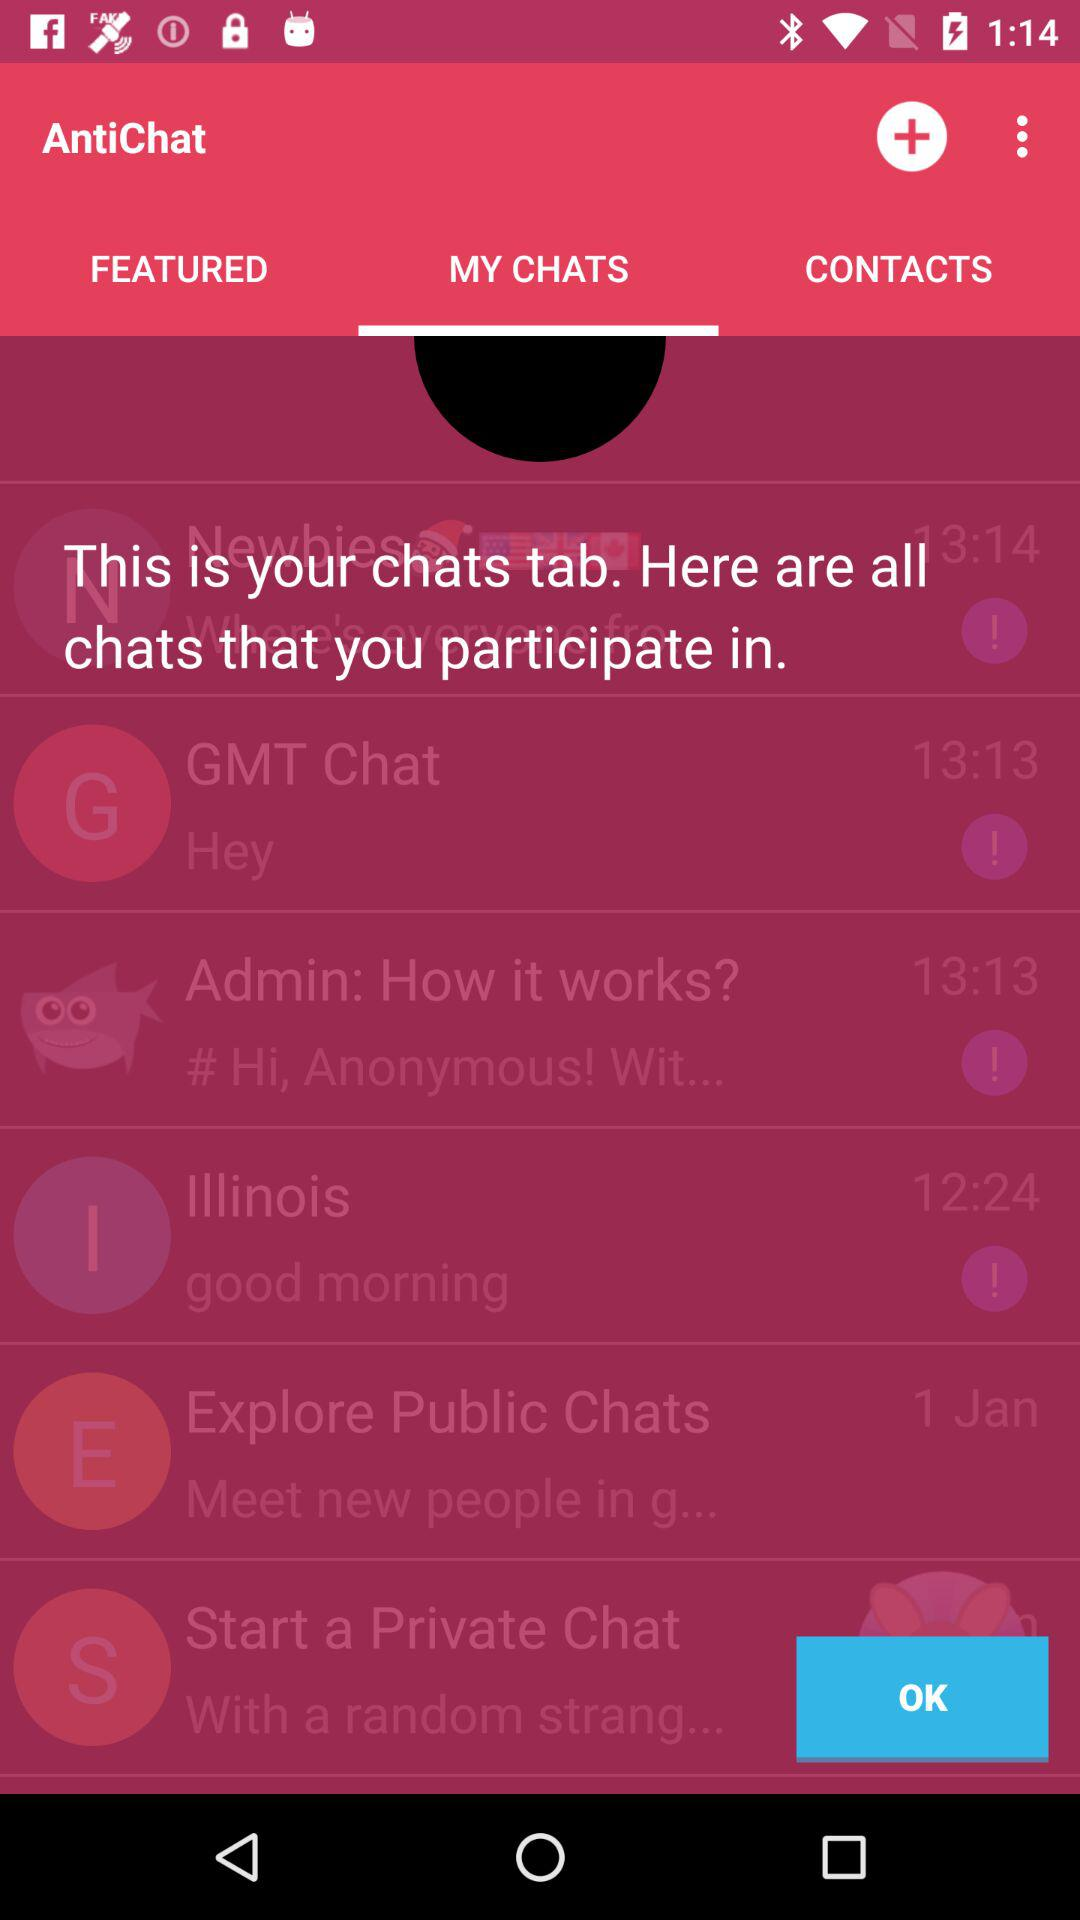What is the name of the application? The application name is "AntiChat". 